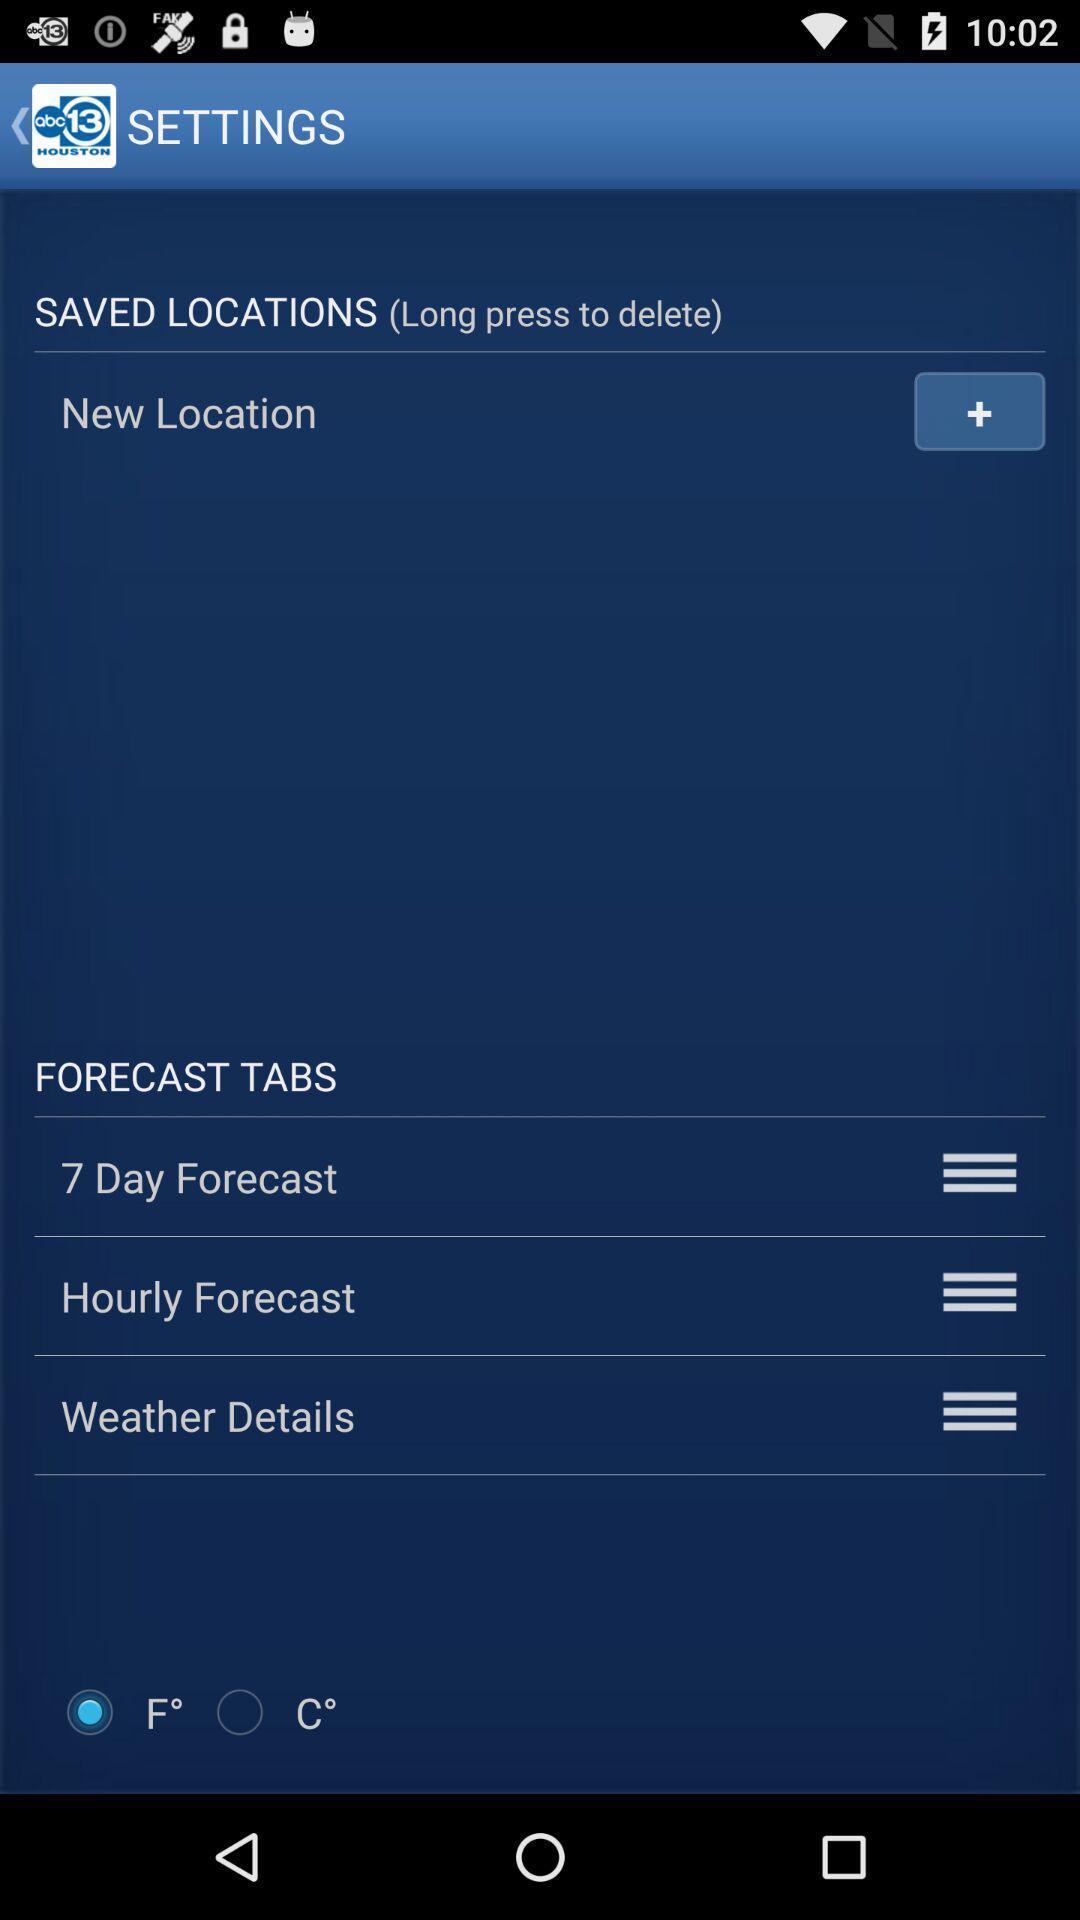What is the overall content of this screenshot? Settings page displaying various options in weather application. 